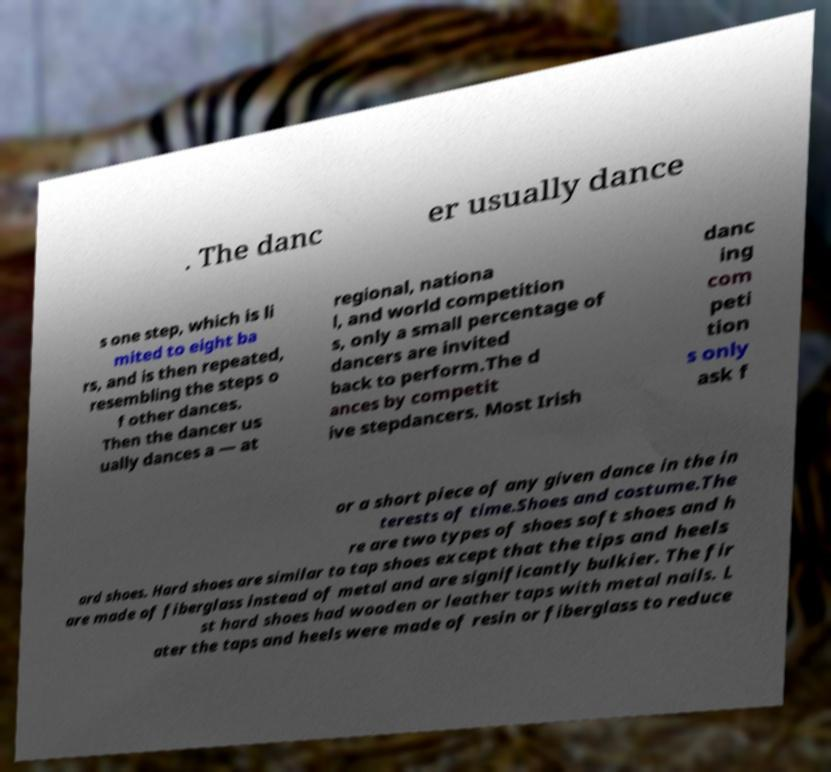Can you accurately transcribe the text from the provided image for me? . The danc er usually dance s one step, which is li mited to eight ba rs, and is then repeated, resembling the steps o f other dances. Then the dancer us ually dances a — at regional, nationa l, and world competition s, only a small percentage of dancers are invited back to perform.The d ances by competit ive stepdancers. Most Irish danc ing com peti tion s only ask f or a short piece of any given dance in the in terests of time.Shoes and costume.The re are two types of shoes soft shoes and h ard shoes. Hard shoes are similar to tap shoes except that the tips and heels are made of fiberglass instead of metal and are significantly bulkier. The fir st hard shoes had wooden or leather taps with metal nails. L ater the taps and heels were made of resin or fiberglass to reduce 